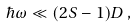Convert formula to latex. <formula><loc_0><loc_0><loc_500><loc_500>\hbar { \omega } \ll { ( 2 S - 1 ) D } \, ,</formula> 